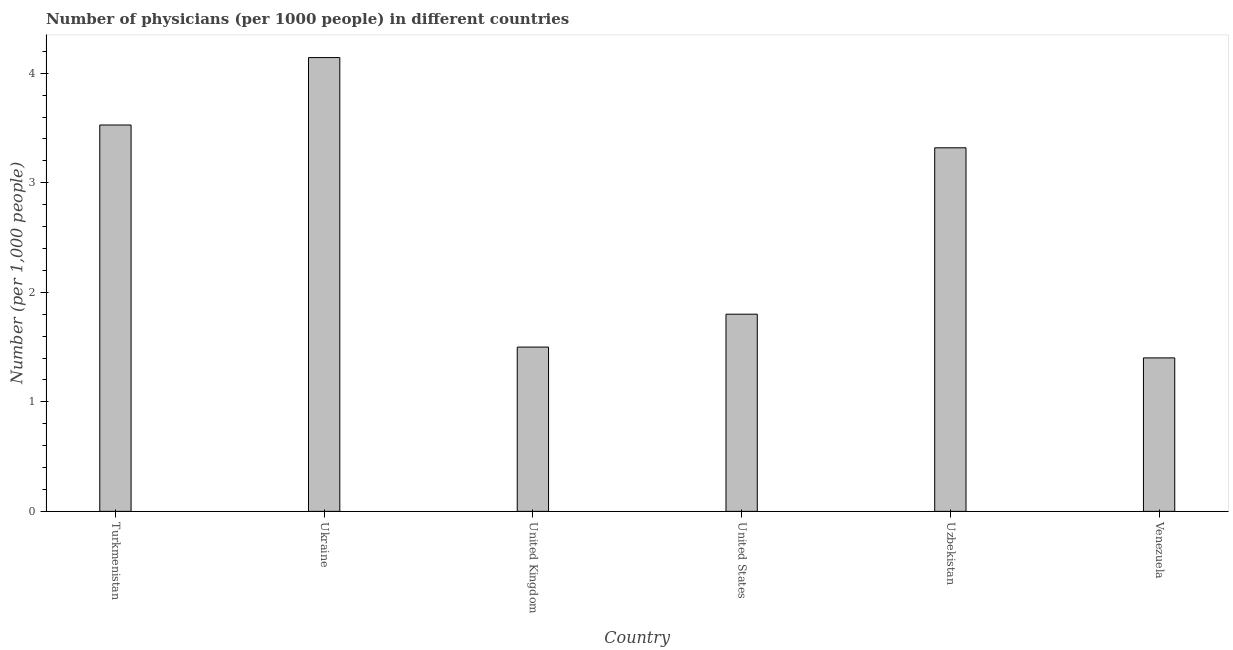What is the title of the graph?
Keep it short and to the point. Number of physicians (per 1000 people) in different countries. What is the label or title of the Y-axis?
Give a very brief answer. Number (per 1,0 people). What is the number of physicians in Venezuela?
Keep it short and to the point. 1.4. Across all countries, what is the maximum number of physicians?
Provide a succinct answer. 4.14. Across all countries, what is the minimum number of physicians?
Your answer should be very brief. 1.4. In which country was the number of physicians maximum?
Your answer should be compact. Ukraine. In which country was the number of physicians minimum?
Your answer should be very brief. Venezuela. What is the sum of the number of physicians?
Ensure brevity in your answer.  15.69. What is the difference between the number of physicians in Turkmenistan and Ukraine?
Give a very brief answer. -0.62. What is the average number of physicians per country?
Provide a succinct answer. 2.62. What is the median number of physicians?
Offer a very short reply. 2.56. What is the ratio of the number of physicians in United Kingdom to that in United States?
Provide a succinct answer. 0.83. Is the number of physicians in Ukraine less than that in United Kingdom?
Give a very brief answer. No. What is the difference between the highest and the second highest number of physicians?
Your answer should be compact. 0.62. What is the difference between the highest and the lowest number of physicians?
Give a very brief answer. 2.74. In how many countries, is the number of physicians greater than the average number of physicians taken over all countries?
Keep it short and to the point. 3. How many bars are there?
Keep it short and to the point. 6. How many countries are there in the graph?
Your answer should be compact. 6. What is the difference between two consecutive major ticks on the Y-axis?
Your answer should be very brief. 1. Are the values on the major ticks of Y-axis written in scientific E-notation?
Offer a very short reply. No. What is the Number (per 1,000 people) of Turkmenistan?
Provide a short and direct response. 3.53. What is the Number (per 1,000 people) in Ukraine?
Ensure brevity in your answer.  4.14. What is the Number (per 1,000 people) of United States?
Make the answer very short. 1.8. What is the Number (per 1,000 people) of Uzbekistan?
Your answer should be very brief. 3.32. What is the Number (per 1,000 people) of Venezuela?
Your response must be concise. 1.4. What is the difference between the Number (per 1,000 people) in Turkmenistan and Ukraine?
Offer a very short reply. -0.62. What is the difference between the Number (per 1,000 people) in Turkmenistan and United Kingdom?
Your answer should be very brief. 2.03. What is the difference between the Number (per 1,000 people) in Turkmenistan and United States?
Your answer should be compact. 1.73. What is the difference between the Number (per 1,000 people) in Turkmenistan and Uzbekistan?
Ensure brevity in your answer.  0.21. What is the difference between the Number (per 1,000 people) in Turkmenistan and Venezuela?
Provide a succinct answer. 2.13. What is the difference between the Number (per 1,000 people) in Ukraine and United Kingdom?
Give a very brief answer. 2.64. What is the difference between the Number (per 1,000 people) in Ukraine and United States?
Offer a terse response. 2.34. What is the difference between the Number (per 1,000 people) in Ukraine and Uzbekistan?
Ensure brevity in your answer.  0.82. What is the difference between the Number (per 1,000 people) in Ukraine and Venezuela?
Provide a short and direct response. 2.74. What is the difference between the Number (per 1,000 people) in United Kingdom and United States?
Make the answer very short. -0.3. What is the difference between the Number (per 1,000 people) in United Kingdom and Uzbekistan?
Offer a terse response. -1.82. What is the difference between the Number (per 1,000 people) in United Kingdom and Venezuela?
Provide a succinct answer. 0.1. What is the difference between the Number (per 1,000 people) in United States and Uzbekistan?
Your answer should be very brief. -1.52. What is the difference between the Number (per 1,000 people) in United States and Venezuela?
Keep it short and to the point. 0.4. What is the difference between the Number (per 1,000 people) in Uzbekistan and Venezuela?
Provide a succinct answer. 1.92. What is the ratio of the Number (per 1,000 people) in Turkmenistan to that in Ukraine?
Offer a very short reply. 0.85. What is the ratio of the Number (per 1,000 people) in Turkmenistan to that in United Kingdom?
Give a very brief answer. 2.35. What is the ratio of the Number (per 1,000 people) in Turkmenistan to that in United States?
Give a very brief answer. 1.96. What is the ratio of the Number (per 1,000 people) in Turkmenistan to that in Uzbekistan?
Offer a terse response. 1.06. What is the ratio of the Number (per 1,000 people) in Turkmenistan to that in Venezuela?
Make the answer very short. 2.52. What is the ratio of the Number (per 1,000 people) in Ukraine to that in United Kingdom?
Provide a short and direct response. 2.76. What is the ratio of the Number (per 1,000 people) in Ukraine to that in United States?
Provide a short and direct response. 2.3. What is the ratio of the Number (per 1,000 people) in Ukraine to that in Uzbekistan?
Keep it short and to the point. 1.25. What is the ratio of the Number (per 1,000 people) in Ukraine to that in Venezuela?
Offer a terse response. 2.96. What is the ratio of the Number (per 1,000 people) in United Kingdom to that in United States?
Keep it short and to the point. 0.83. What is the ratio of the Number (per 1,000 people) in United Kingdom to that in Uzbekistan?
Give a very brief answer. 0.45. What is the ratio of the Number (per 1,000 people) in United Kingdom to that in Venezuela?
Keep it short and to the point. 1.07. What is the ratio of the Number (per 1,000 people) in United States to that in Uzbekistan?
Your answer should be compact. 0.54. What is the ratio of the Number (per 1,000 people) in United States to that in Venezuela?
Your response must be concise. 1.28. What is the ratio of the Number (per 1,000 people) in Uzbekistan to that in Venezuela?
Your answer should be compact. 2.37. 